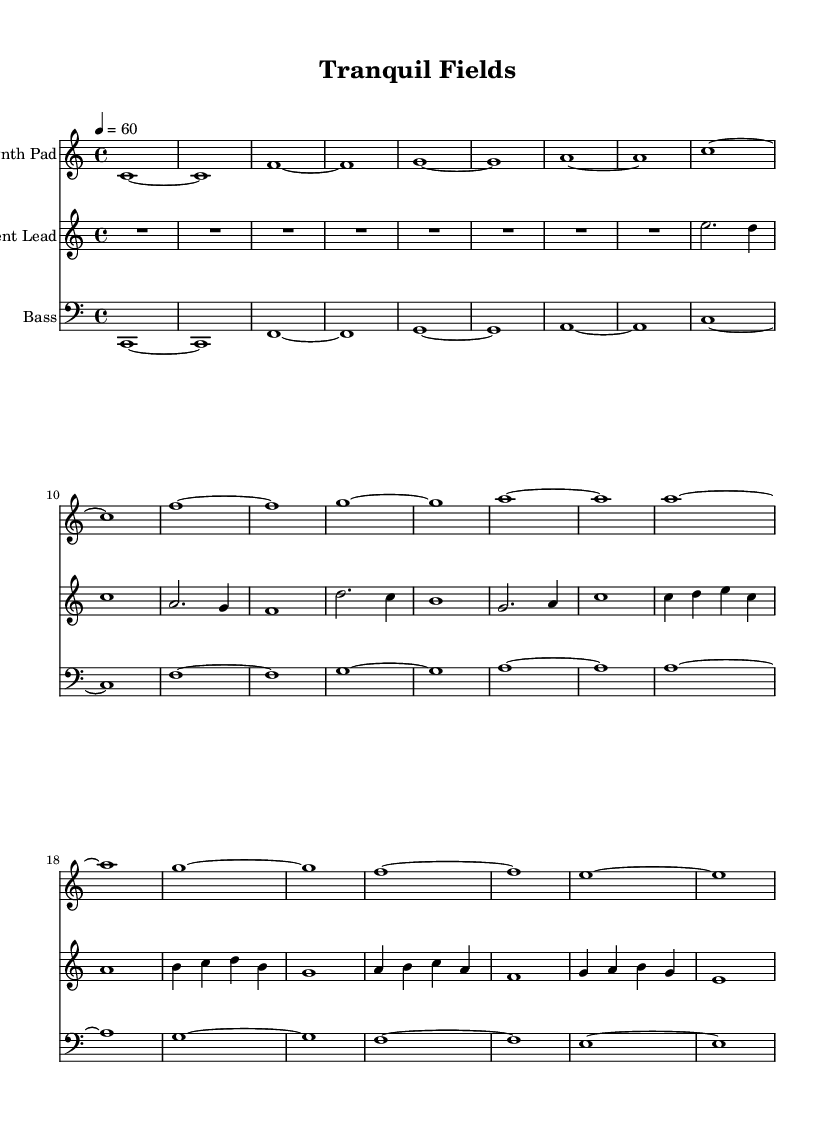What is the key signature of this music? The key signature is C major, which has no sharps or flats.
Answer: C major What is the time signature used in the piece? The time signature is indicated as 4/4, meaning there are four beats in each measure.
Answer: 4/4 What is the tempo marking for this piece? The tempo marking is quarter note equals 60, indicating a slow pace.
Answer: 60 How many measures are in the synth pad section? The synth pad section consists of 8 measures, as indicated by the repeated pattern throughout.
Answer: 8 What type of instrument is indicated for the first staff? The first staff is labeled as "Synth Pad," indicating an electronic pad sound.
Answer: Synth Pad Which note serves as the starting pitch for the ambient lead section? The ambient lead section begins with an E note, as shown in the notation of the first measure.
Answer: E What is the primary function of the bass line in this arrangement? The bass line typically provides support and depth, grounding the harmony under the synth and lead parts.
Answer: Support 